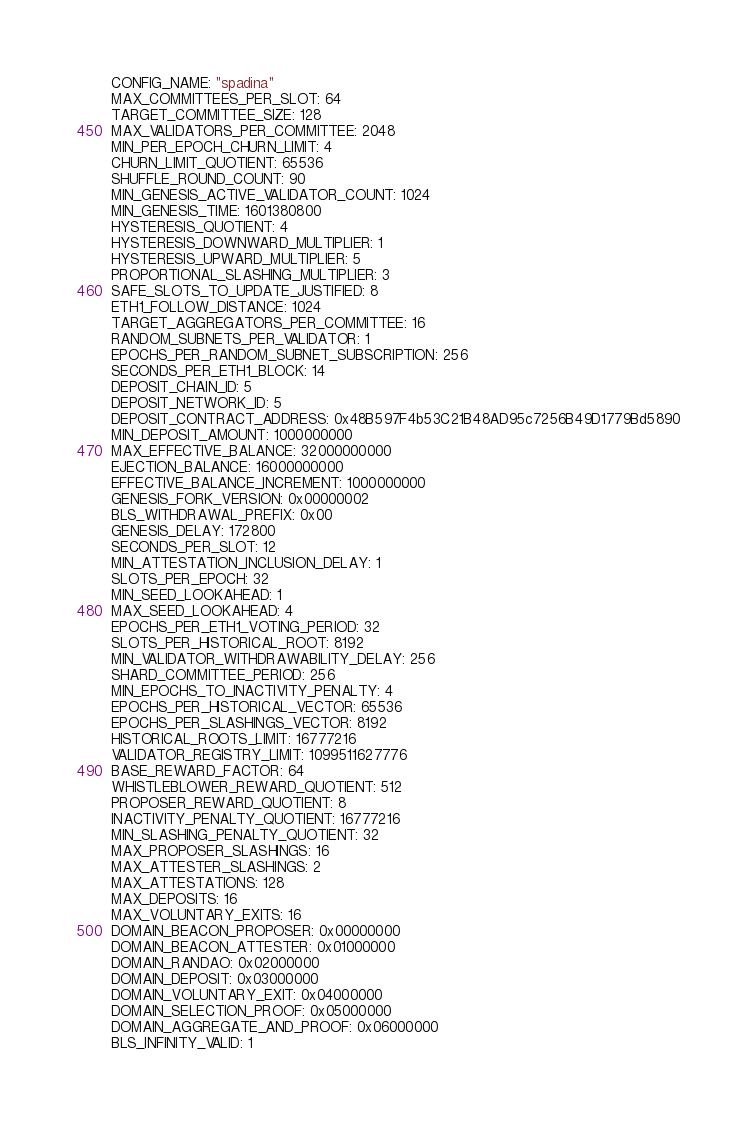Convert code to text. <code><loc_0><loc_0><loc_500><loc_500><_YAML_>CONFIG_NAME: "spadina"
MAX_COMMITTEES_PER_SLOT: 64
TARGET_COMMITTEE_SIZE: 128
MAX_VALIDATORS_PER_COMMITTEE: 2048
MIN_PER_EPOCH_CHURN_LIMIT: 4
CHURN_LIMIT_QUOTIENT: 65536
SHUFFLE_ROUND_COUNT: 90
MIN_GENESIS_ACTIVE_VALIDATOR_COUNT: 1024
MIN_GENESIS_TIME: 1601380800
HYSTERESIS_QUOTIENT: 4
HYSTERESIS_DOWNWARD_MULTIPLIER: 1
HYSTERESIS_UPWARD_MULTIPLIER: 5
PROPORTIONAL_SLASHING_MULTIPLIER: 3
SAFE_SLOTS_TO_UPDATE_JUSTIFIED: 8
ETH1_FOLLOW_DISTANCE: 1024
TARGET_AGGREGATORS_PER_COMMITTEE: 16
RANDOM_SUBNETS_PER_VALIDATOR: 1
EPOCHS_PER_RANDOM_SUBNET_SUBSCRIPTION: 256
SECONDS_PER_ETH1_BLOCK: 14
DEPOSIT_CHAIN_ID: 5
DEPOSIT_NETWORK_ID: 5
DEPOSIT_CONTRACT_ADDRESS: 0x48B597F4b53C21B48AD95c7256B49D1779Bd5890
MIN_DEPOSIT_AMOUNT: 1000000000
MAX_EFFECTIVE_BALANCE: 32000000000
EJECTION_BALANCE: 16000000000
EFFECTIVE_BALANCE_INCREMENT: 1000000000
GENESIS_FORK_VERSION: 0x00000002
BLS_WITHDRAWAL_PREFIX: 0x00
GENESIS_DELAY: 172800
SECONDS_PER_SLOT: 12
MIN_ATTESTATION_INCLUSION_DELAY: 1
SLOTS_PER_EPOCH: 32
MIN_SEED_LOOKAHEAD: 1
MAX_SEED_LOOKAHEAD: 4
EPOCHS_PER_ETH1_VOTING_PERIOD: 32
SLOTS_PER_HISTORICAL_ROOT: 8192
MIN_VALIDATOR_WITHDRAWABILITY_DELAY: 256
SHARD_COMMITTEE_PERIOD: 256
MIN_EPOCHS_TO_INACTIVITY_PENALTY: 4
EPOCHS_PER_HISTORICAL_VECTOR: 65536
EPOCHS_PER_SLASHINGS_VECTOR: 8192
HISTORICAL_ROOTS_LIMIT: 16777216
VALIDATOR_REGISTRY_LIMIT: 1099511627776
BASE_REWARD_FACTOR: 64
WHISTLEBLOWER_REWARD_QUOTIENT: 512
PROPOSER_REWARD_QUOTIENT: 8
INACTIVITY_PENALTY_QUOTIENT: 16777216
MIN_SLASHING_PENALTY_QUOTIENT: 32
MAX_PROPOSER_SLASHINGS: 16
MAX_ATTESTER_SLASHINGS: 2
MAX_ATTESTATIONS: 128
MAX_DEPOSITS: 16
MAX_VOLUNTARY_EXITS: 16
DOMAIN_BEACON_PROPOSER: 0x00000000
DOMAIN_BEACON_ATTESTER: 0x01000000
DOMAIN_RANDAO: 0x02000000
DOMAIN_DEPOSIT: 0x03000000
DOMAIN_VOLUNTARY_EXIT: 0x04000000
DOMAIN_SELECTION_PROOF: 0x05000000
DOMAIN_AGGREGATE_AND_PROOF: 0x06000000
BLS_INFINITY_VALID: 1</code> 